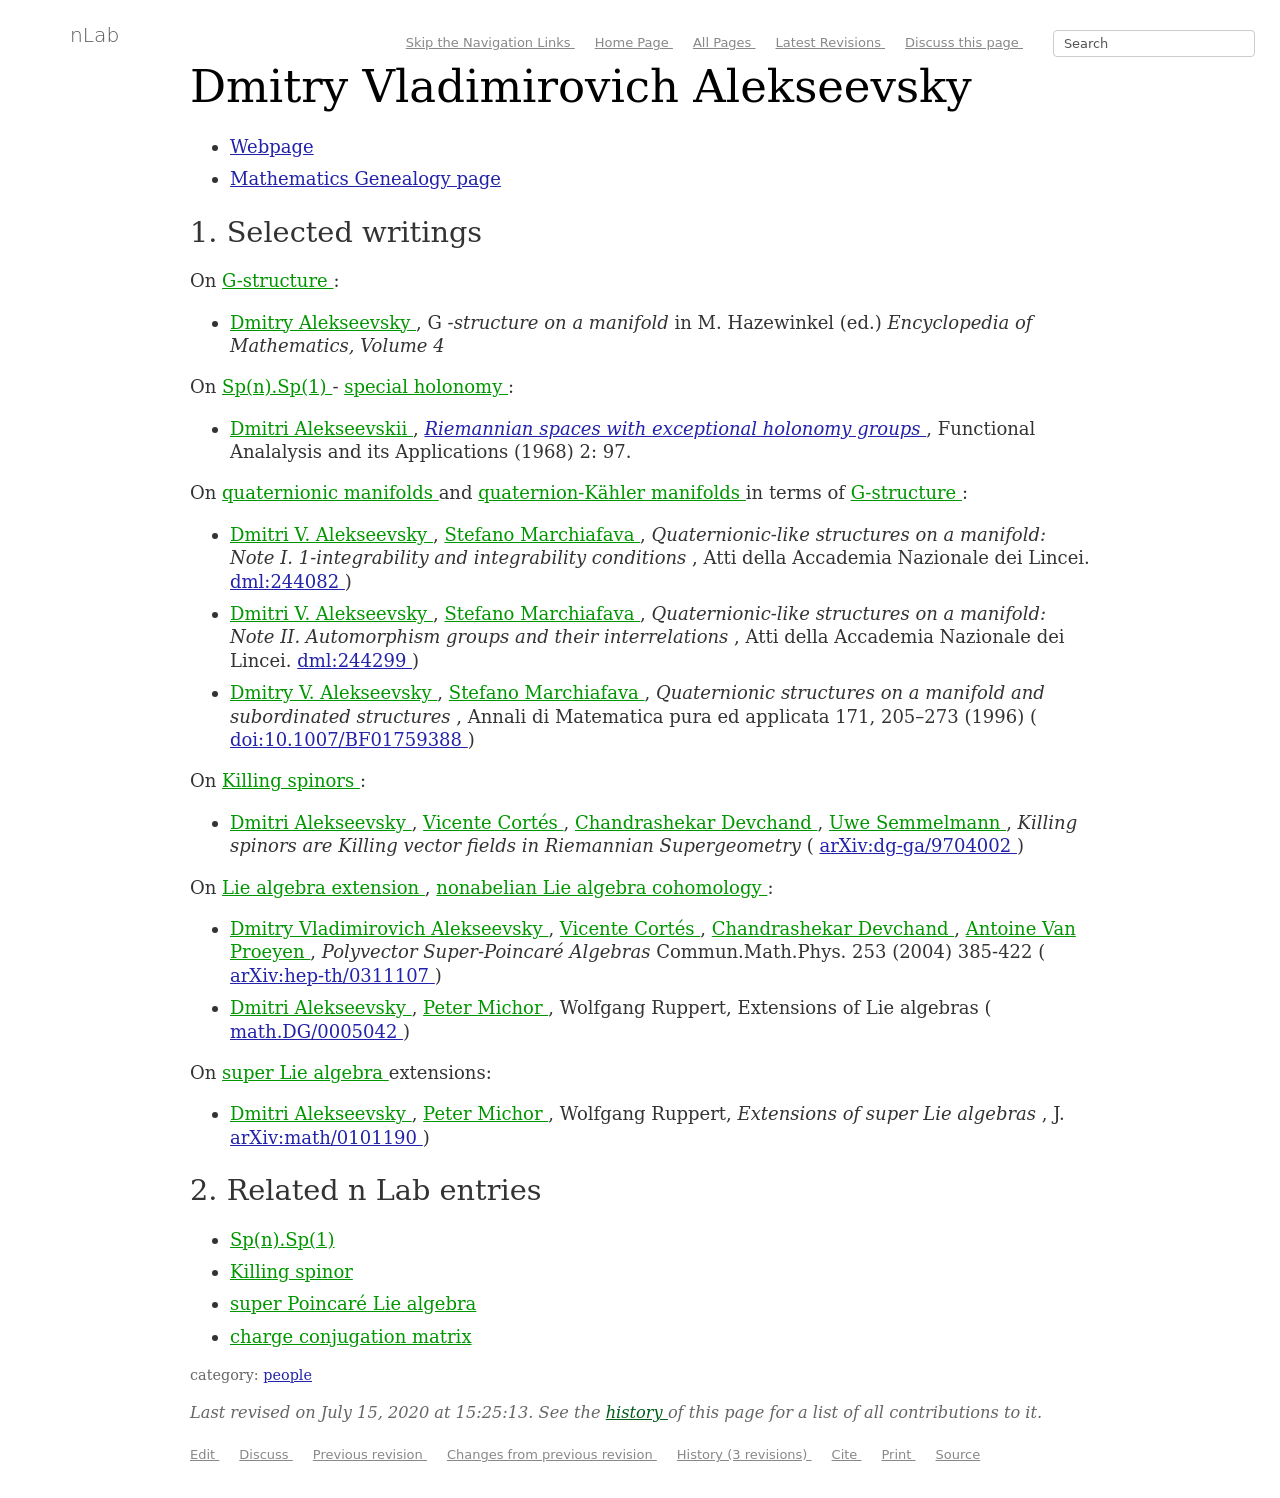Could you provide more details about the 'G-structure on a manifold' in the writings of Dmitry Vladimirovich Alekseevsky? The 'G-structure on a manifold' refers to a mathematical framework used in differential geometry. It allows for generalizations of structures on differentiable manifolds, classifying manifolds with specific geometric properties. It’s applied in various aspects of theoretical physics and geometry.  How significant are his contributions to the field? Dmitry Vladimirovich Alekseevsky is highly regarded for his deep and extensive work in differential geometry and its applications to physics. His contributions, such as exploring exceptional holonomy groups and quaternionic structures, are pivotal and have led to a richer understanding of the mathematical underpinnings of the universe's structure. 